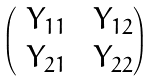<formula> <loc_0><loc_0><loc_500><loc_500>\begin{pmatrix} \ Y _ { 1 1 } & \ Y _ { 1 2 } \\ \ Y _ { 2 1 } & \ Y _ { 2 2 } \end{pmatrix}</formula> 